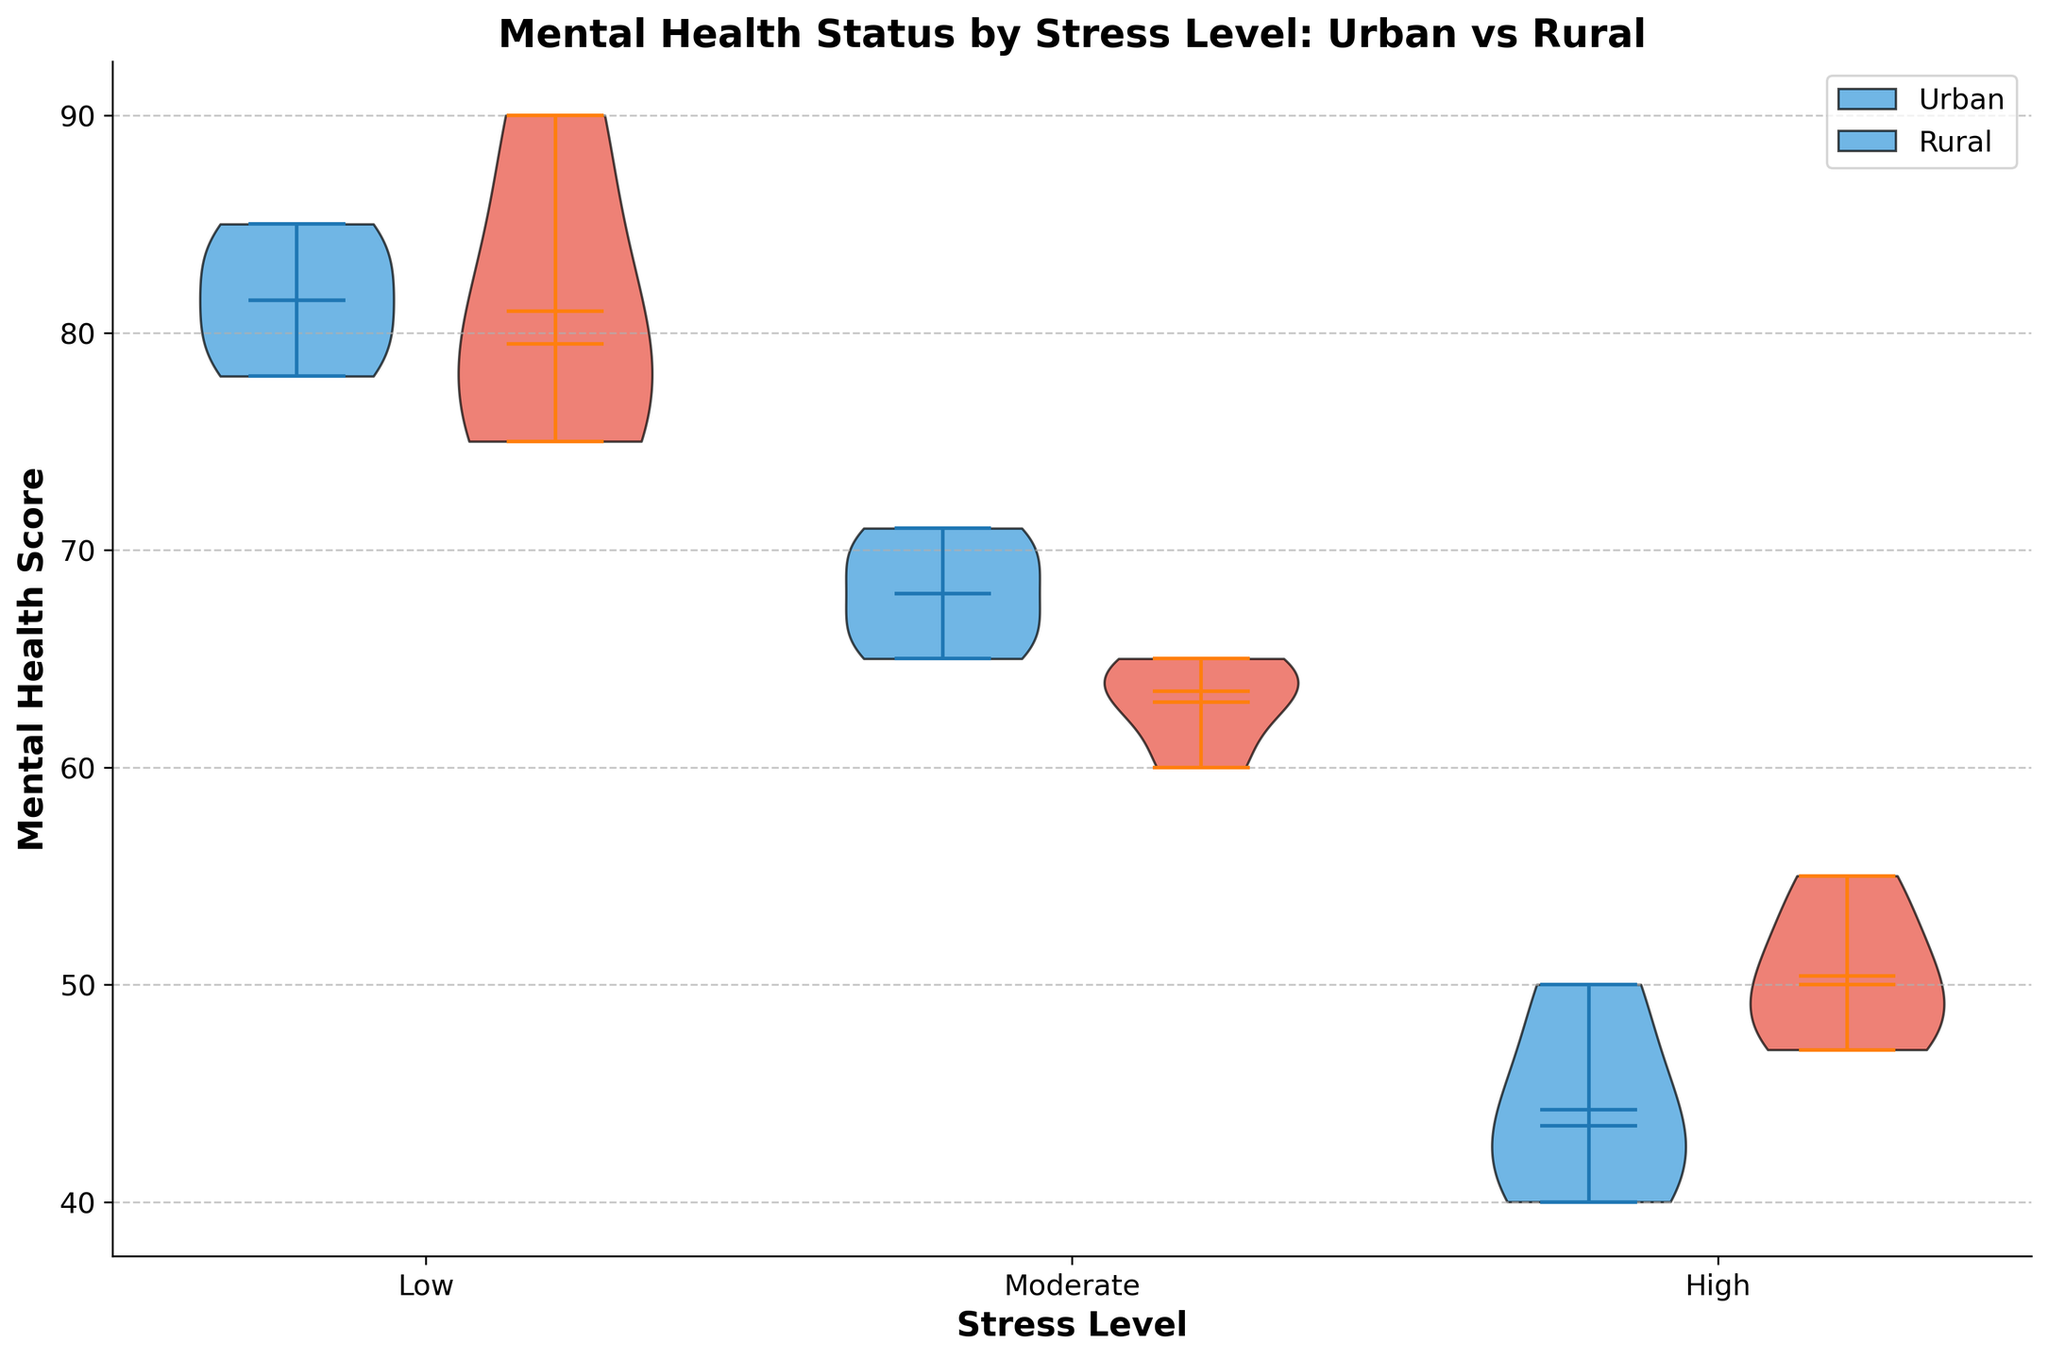What's the title of the figure? The title of the figure is displayed prominently at the top.
Answer: "Mental Health Status by Stress Level: Urban vs Rural" What are the stress levels shown on the x-axis? The x-axis labels the different stress levels.
Answer: Low, Moderate, High What colors represent urban and rural residents in the figure? The colors of the violin plots indicate different groups. Urban is represented in blue and rural in red.
Answer: Urban: blue, Rural: red Which group has a higher median mental health score for the low-stress level? By examining the central marker of the violins, we can compare the medians.
Answer: Urban What is the range of mental health scores for urban residents with high-stress levels? The range can be observed by looking at the endpoints of the violin plot.
Answer: 40 to 50 For rural residents, which stress level has the widest spread of mental health scores? By comparing the widths of the violin plots across the different stress levels, the widest spread can be determined.
Answer: Low Compare the mean mental health scores for urban and rural residents with moderate stress levels. Which is higher? The mean scores are indicated by the white dots inside the violins. Observe the position of the means in both groups for moderate stress.
Answer: Urban What is the overall pattern observed in mental health scores between urban and rural residents as stress levels increase? Comparing all violin sections for both residents across the stress levels, an overall pattern can be derived.
Answer: Urban residents tend to have slightly better mental health scores than rural residents under all stress levels How do the spreads of mental health scores for urban residents change as the stress level increases? By observing the width of the urban violins for each stress level, we can see how it changes.
Answer: Widest at low stress, narrows as stress increases 